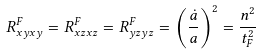<formula> <loc_0><loc_0><loc_500><loc_500>R ^ { F } _ { x y x y } = R ^ { F } _ { x z x z } = R ^ { F } _ { y z y z } = \left ( \frac { \dot { a } } { a } \right ) ^ { 2 } = \frac { n ^ { 2 } } { t _ { F } ^ { 2 } }</formula> 